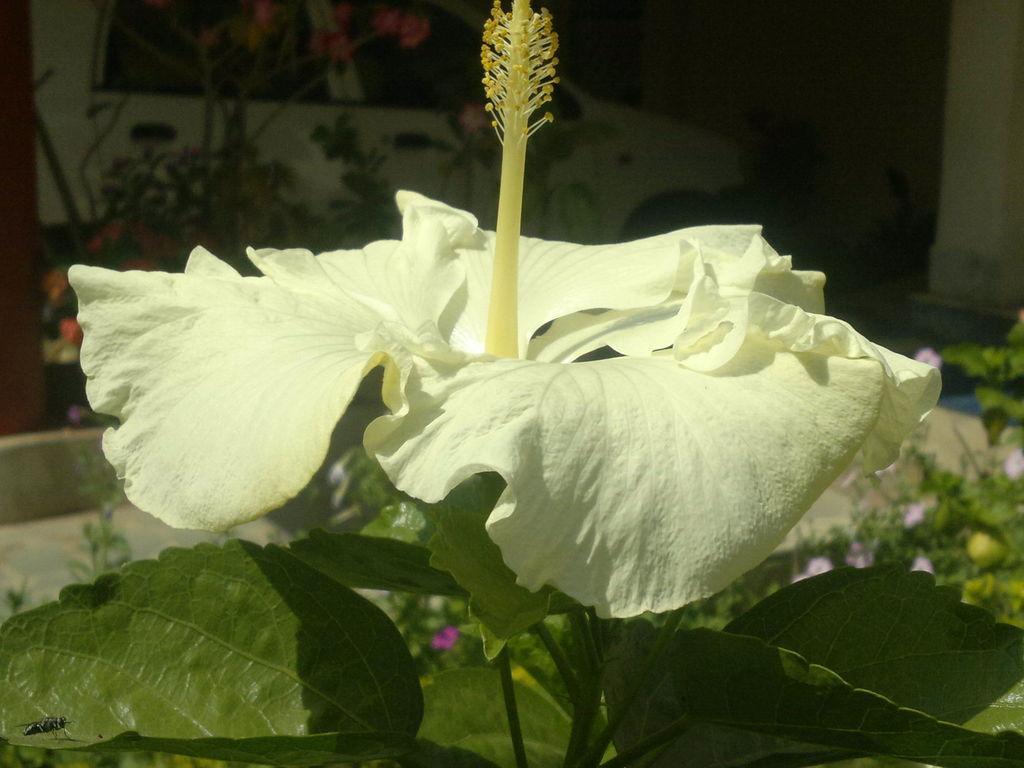In one or two sentences, can you explain what this image depicts? There is a white hibiscus flower on a plant. In the back there are many flowering plants. Also there is a car. 